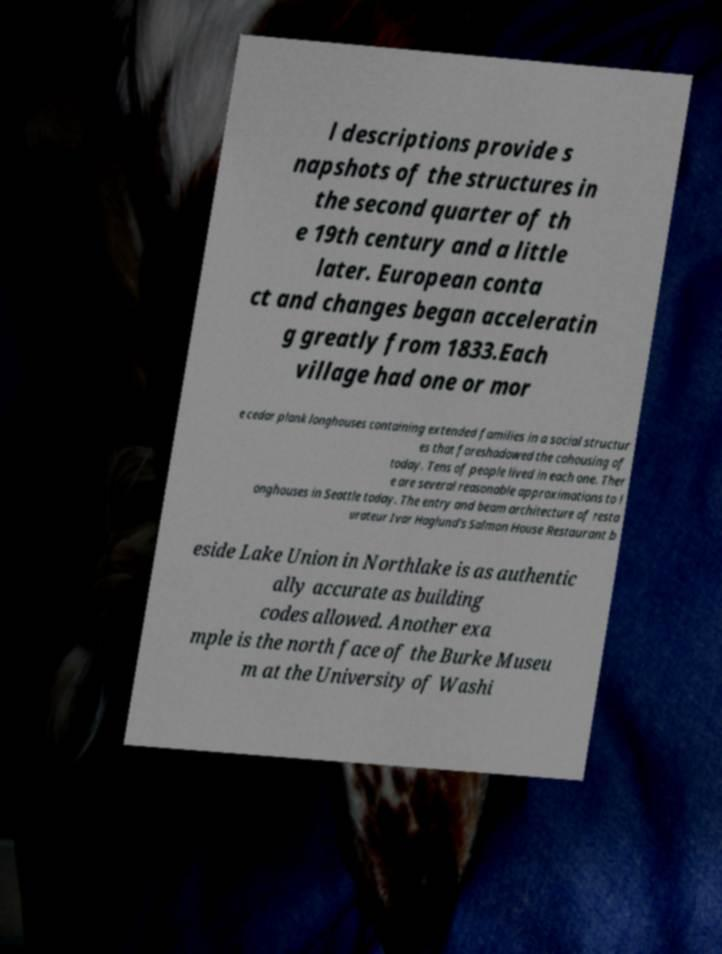For documentation purposes, I need the text within this image transcribed. Could you provide that? l descriptions provide s napshots of the structures in the second quarter of th e 19th century and a little later. European conta ct and changes began acceleratin g greatly from 1833.Each village had one or mor e cedar plank longhouses containing extended families in a social structur es that foreshadowed the cohousing of today. Tens of people lived in each one. Ther e are several reasonable approximations to l onghouses in Seattle today. The entry and beam architecture of resta urateur Ivar Haglund's Salmon House Restaurant b eside Lake Union in Northlake is as authentic ally accurate as building codes allowed. Another exa mple is the north face of the Burke Museu m at the University of Washi 